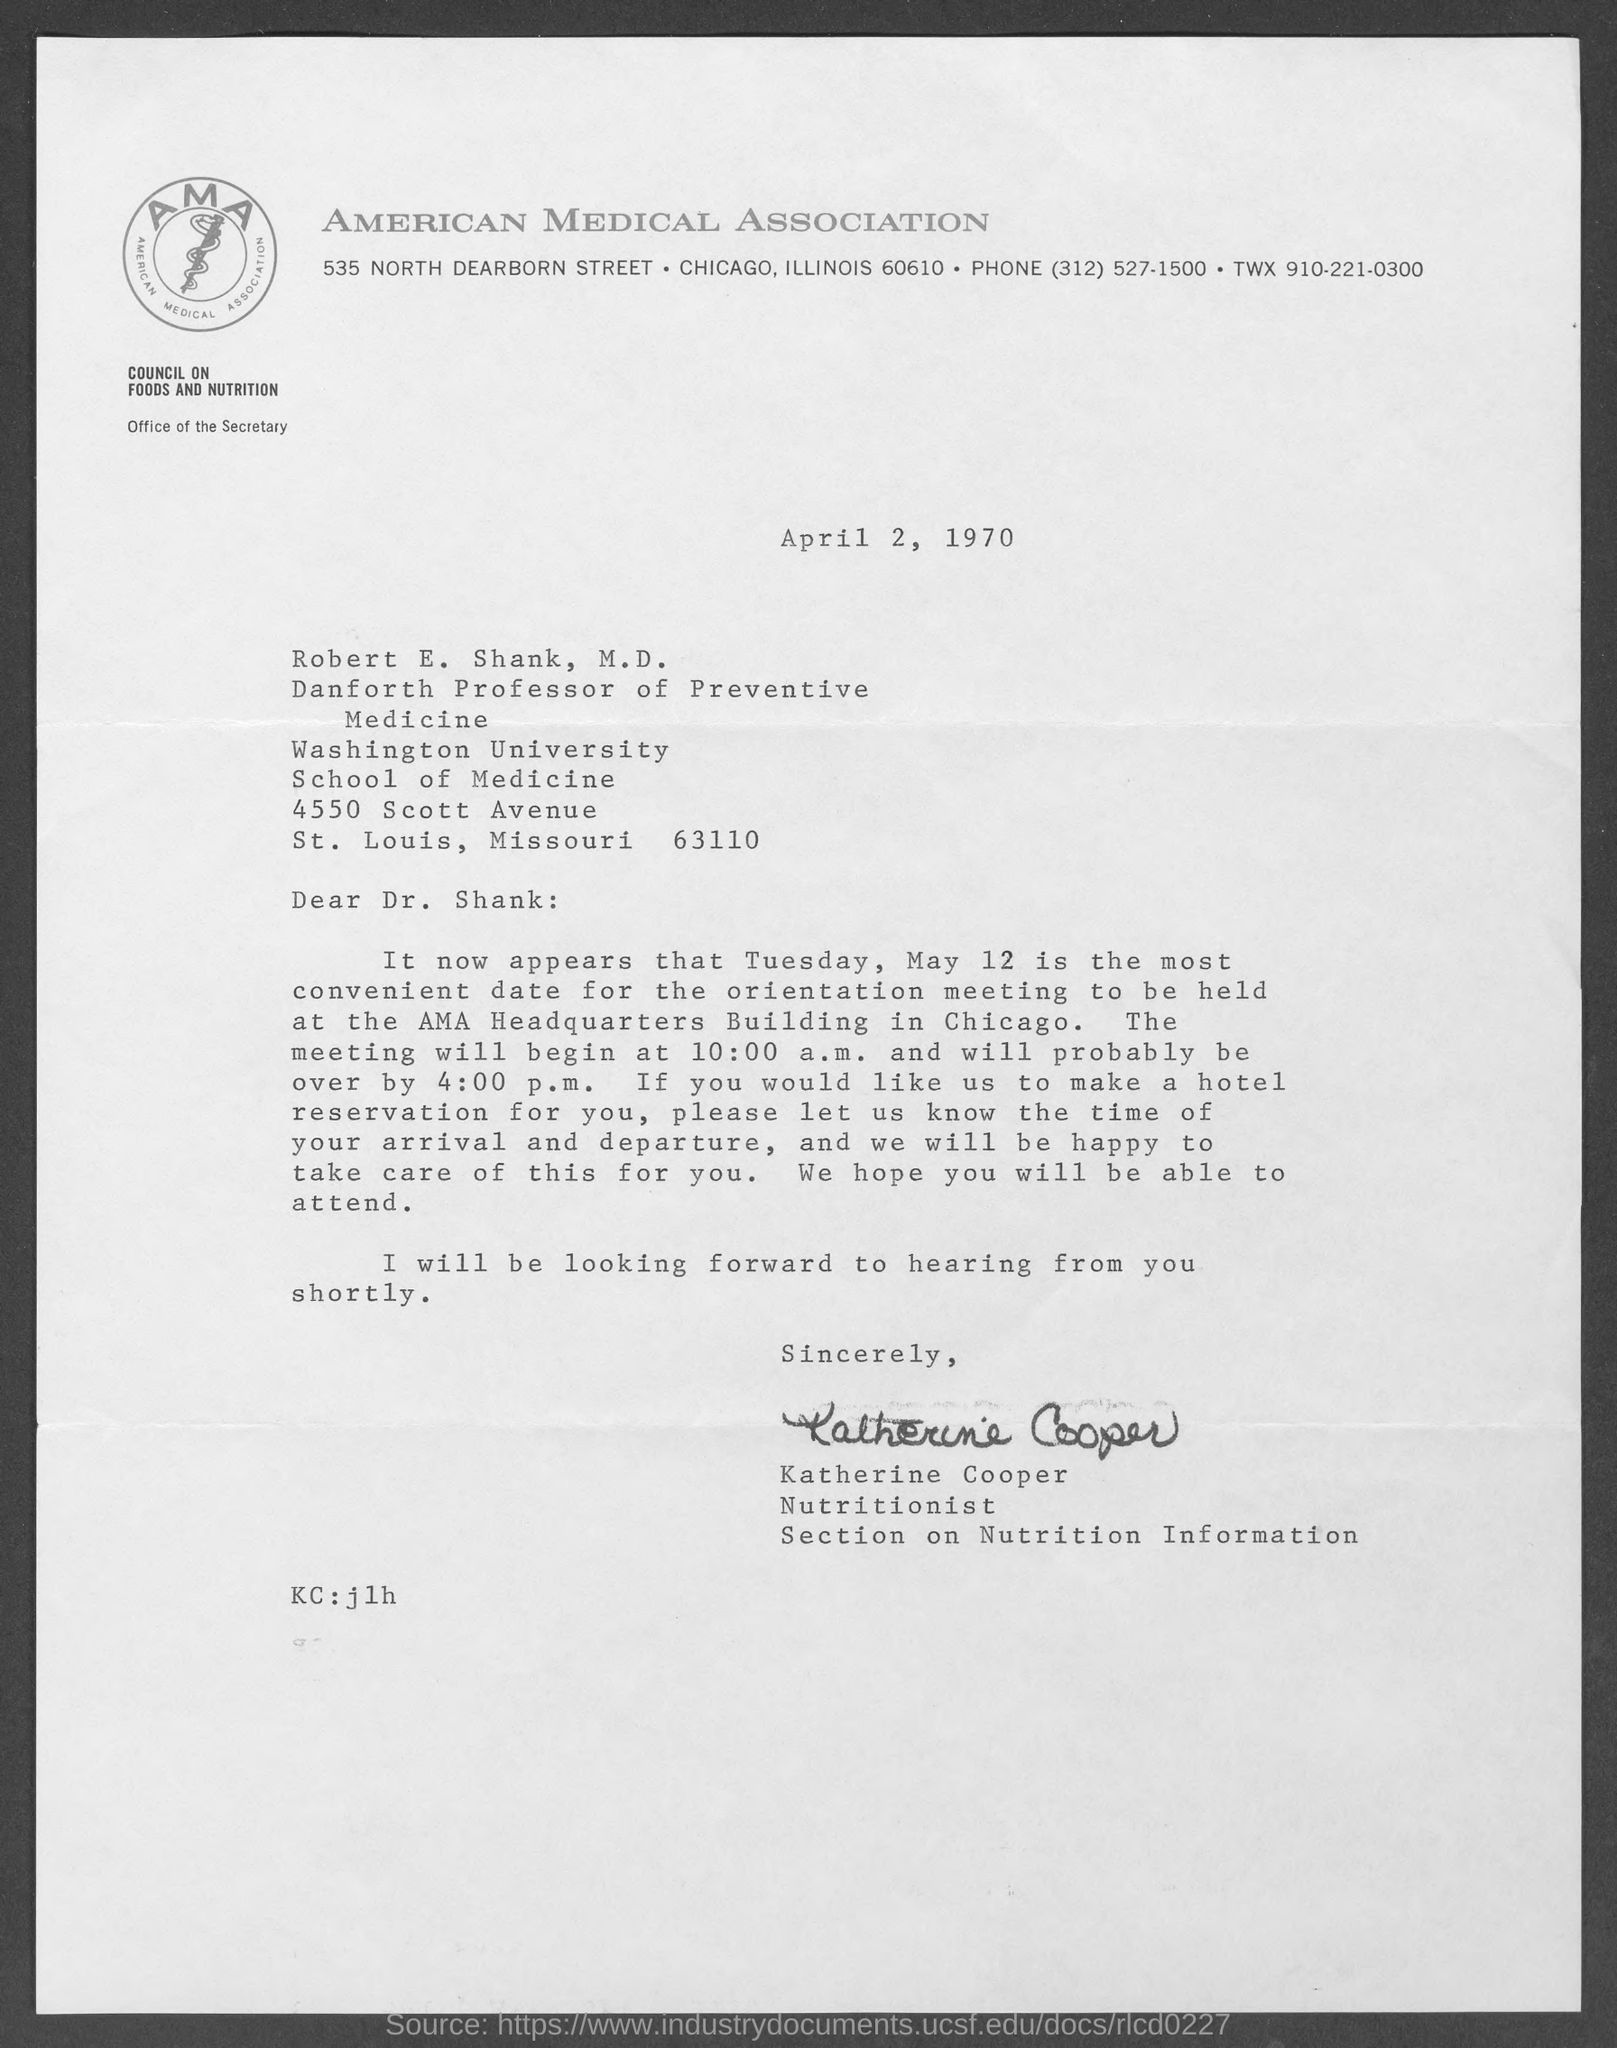When is the document dated?
Your answer should be very brief. April 2, 1970. Where is the orientation meeting going to be held?
Ensure brevity in your answer.  AMA HEADQUARTERS BUILDING IN CHICAGO. Which association is mentioned?
Keep it short and to the point. AMERICAN MEDICAL ASSOCIATION. What is the phone number of American Medical Association?
Offer a very short reply. (312) 527-1500. 